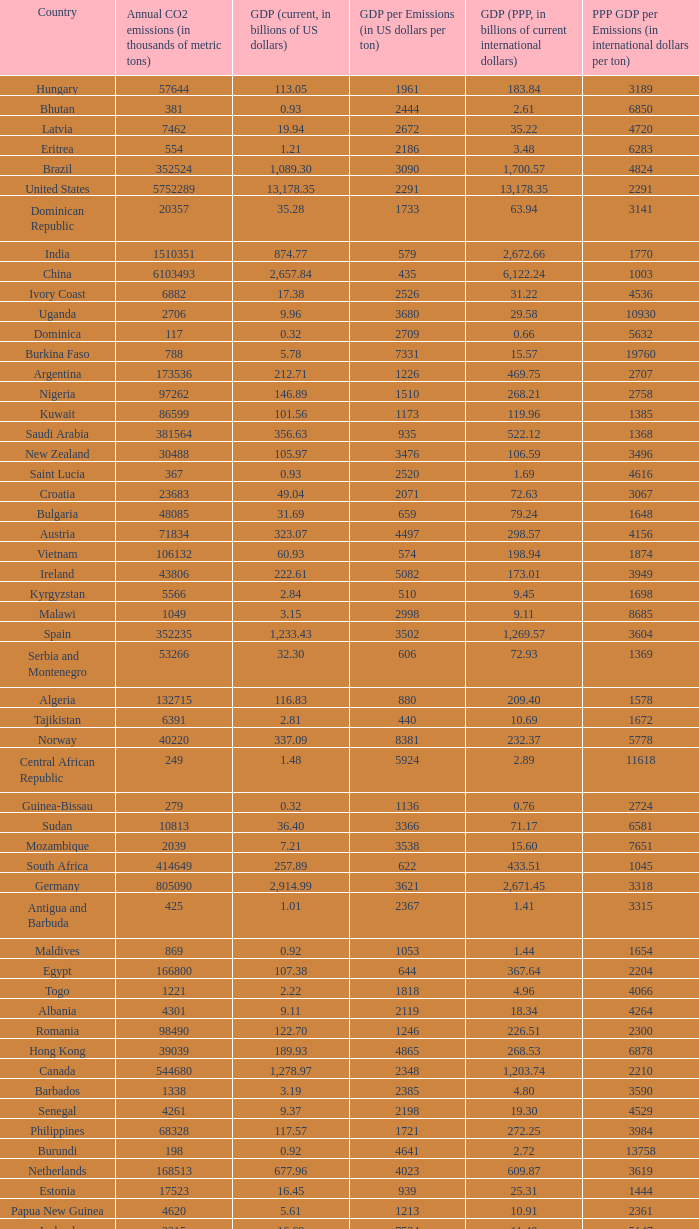When the gdp per emissions (in us dollars per ton) is 3903, what is the maximum annual co2 emissions (in thousands of metric tons)? 935.0. 